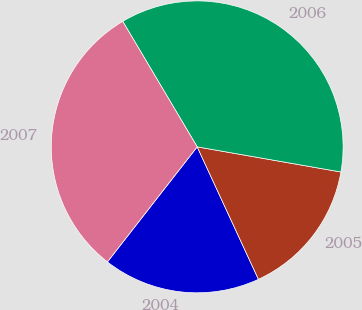Convert chart to OTSL. <chart><loc_0><loc_0><loc_500><loc_500><pie_chart><fcel>2004<fcel>2005<fcel>2006<fcel>2007<nl><fcel>17.44%<fcel>15.35%<fcel>36.28%<fcel>30.93%<nl></chart> 